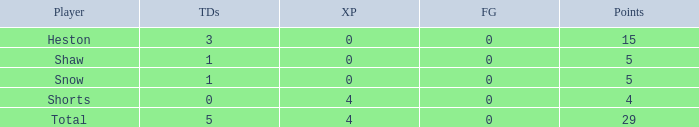What is the total number of field goals a player had when there were more than 0 extra points and there were 5 touchdowns? 1.0. 